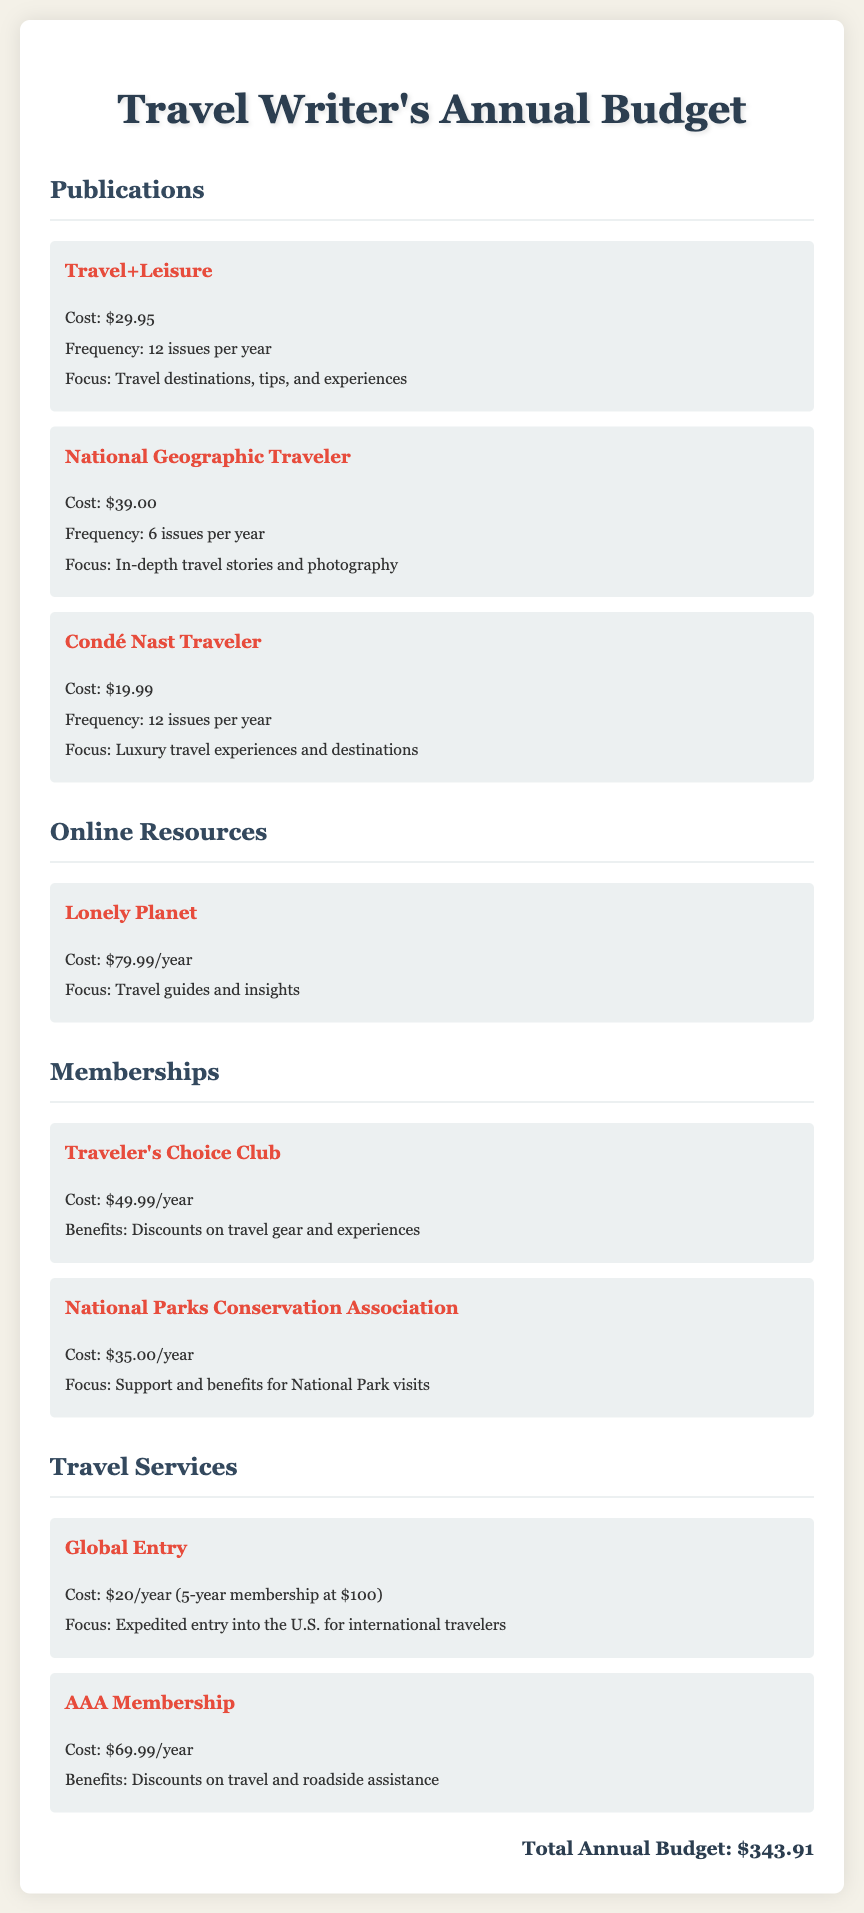what is the cost of Travel+Leisure? The document lists the cost of Travel+Leisure as $29.95.
Answer: $29.95 how many issues does National Geographic Traveler publish per year? The document states that National Geographic Traveler publishes 6 issues per year.
Answer: 6 what is the focus of Condé Nast Traveler? The document describes the focus of Condé Nast Traveler as luxury travel experiences and destinations.
Answer: Luxury travel experiences and destinations what is the total annual budget? The document provides the total annual budget as $343.91.
Answer: $343.91 how much does a Lonely Planet subscription cost? The document states that a Lonely Planet subscription costs $79.99/year.
Answer: $79.99/year which membership offers discounts on travel gear? The document states that the Traveler's Choice Club offers discounts on travel gear and experiences.
Answer: Traveler's Choice Club what is the focus of the National Parks Conservation Association? The document mentions that the focus is on support and benefits for National Park visits.
Answer: Support and benefits for National Park visits how much does AAA Membership cost? According to the document, the cost of AAA Membership is $69.99/year.
Answer: $69.99/year 